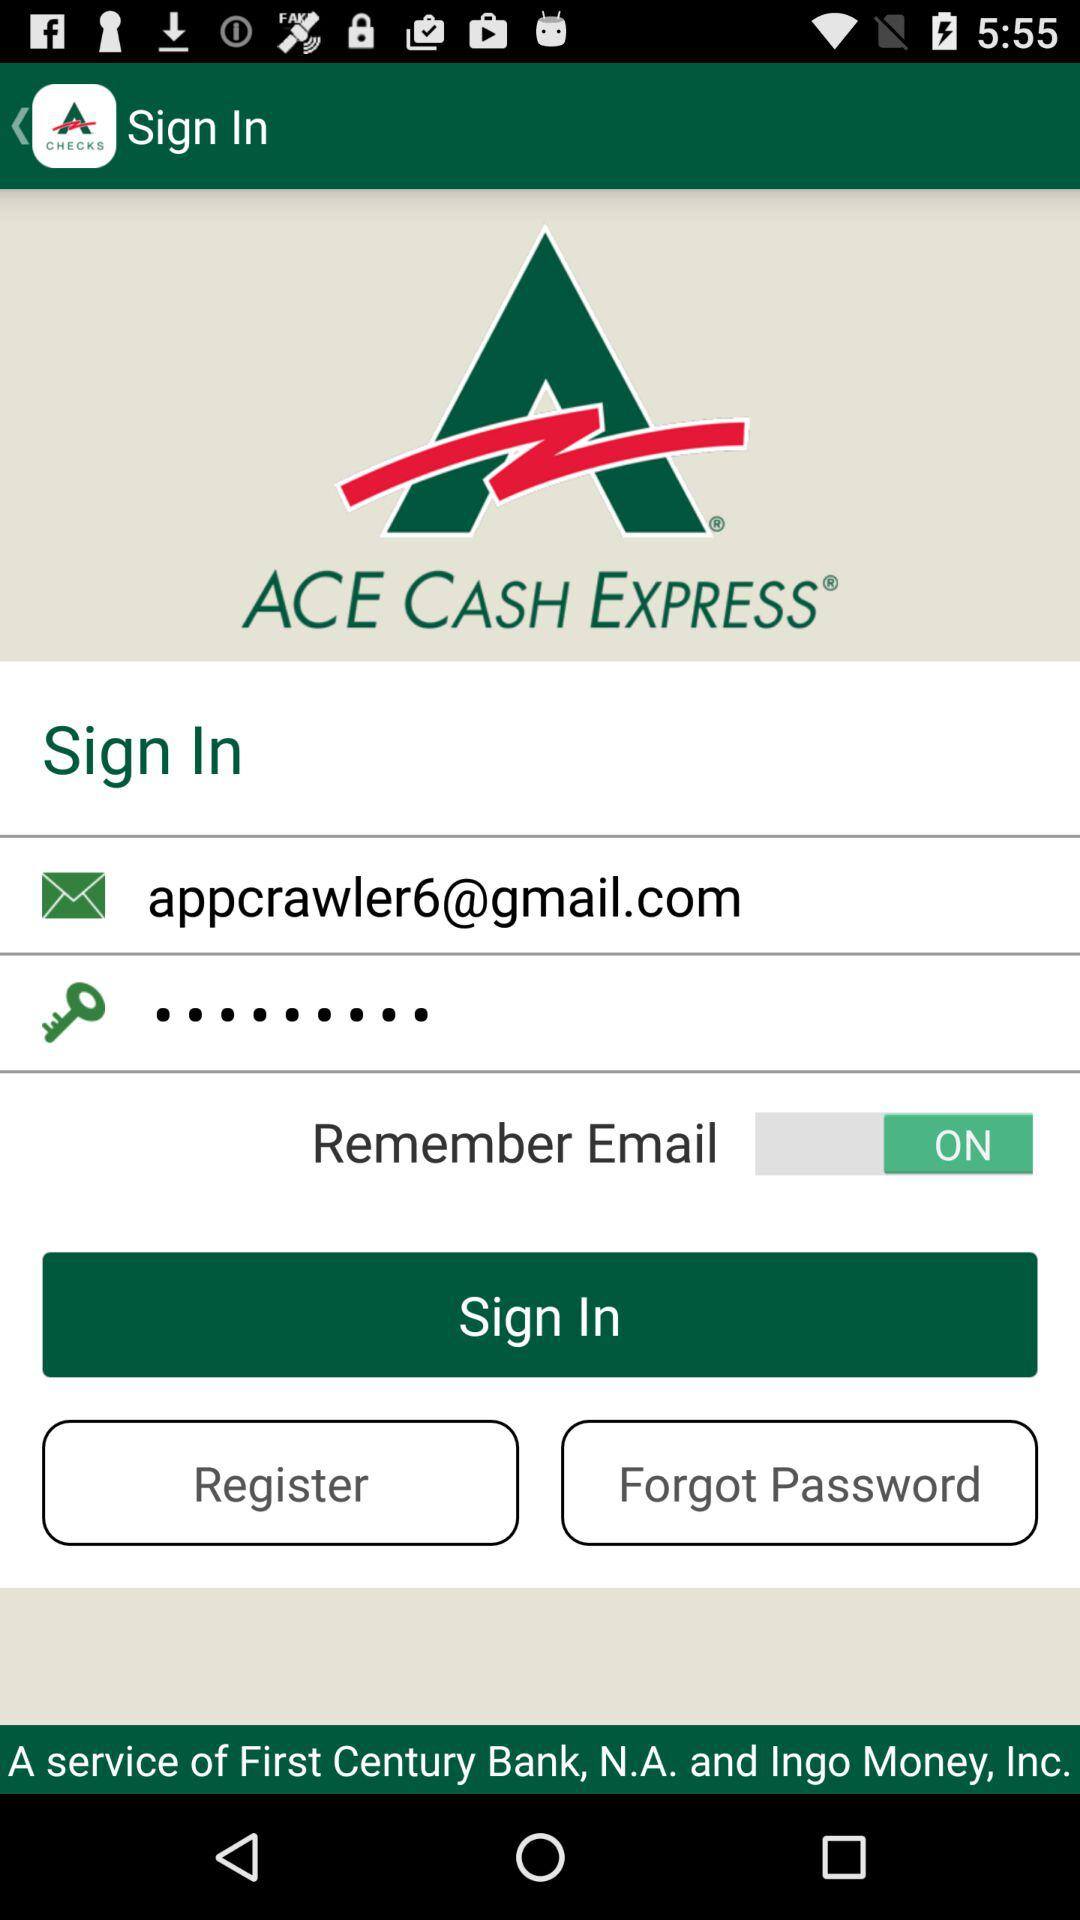What is the status of "Remember Email"? The status is "on". 